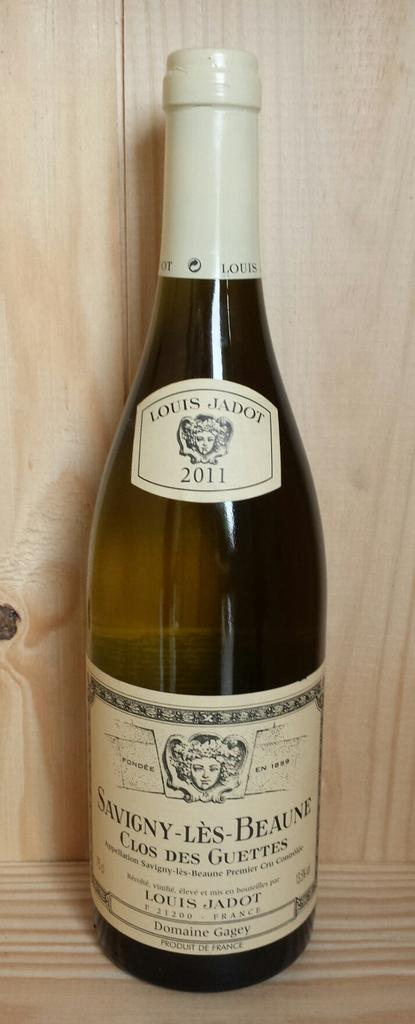<image>
Create a compact narrative representing the image presented. A bottle of Savigny Les Beaune from the year 2011 